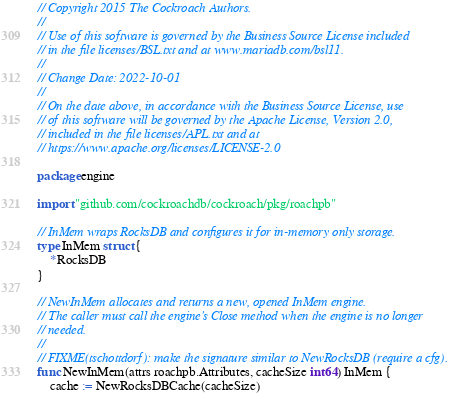<code> <loc_0><loc_0><loc_500><loc_500><_Go_>// Copyright 2015 The Cockroach Authors.
//
// Use of this software is governed by the Business Source License included
// in the file licenses/BSL.txt and at www.mariadb.com/bsl11.
//
// Change Date: 2022-10-01
//
// On the date above, in accordance with the Business Source License, use
// of this software will be governed by the Apache License, Version 2.0,
// included in the file licenses/APL.txt and at
// https://www.apache.org/licenses/LICENSE-2.0

package engine

import "github.com/cockroachdb/cockroach/pkg/roachpb"

// InMem wraps RocksDB and configures it for in-memory only storage.
type InMem struct {
	*RocksDB
}

// NewInMem allocates and returns a new, opened InMem engine.
// The caller must call the engine's Close method when the engine is no longer
// needed.
//
// FIXME(tschottdorf): make the signature similar to NewRocksDB (require a cfg).
func NewInMem(attrs roachpb.Attributes, cacheSize int64) InMem {
	cache := NewRocksDBCache(cacheSize)</code> 